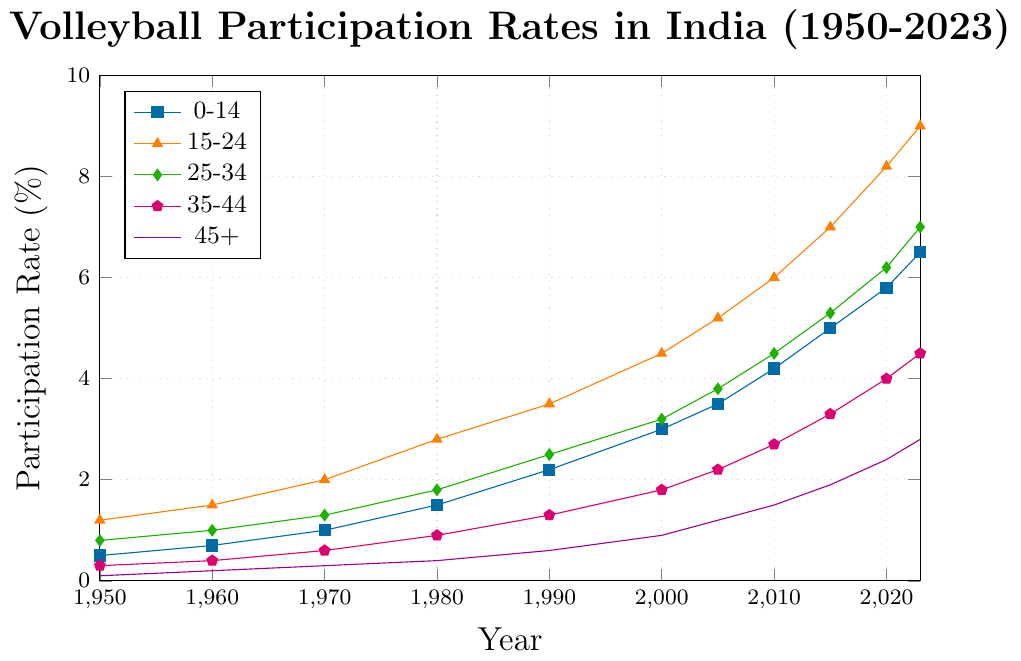What age group had the highest participation rate in 1980? Look at the data points for the year 1980; the age group 15-24 has the highest participation rate with a value of 2.8%.
Answer: 15-24 What is the difference in participation rates between age groups 15-24 and 0-14 in 2000? For the year 2000, look at the participation rates for age groups 15-24 (4.5%) and 0-14 (3.0%) and subtract them (4.5% - 3.0%).
Answer: 1.5% Which age group showed the greatest increase in participation rate from 1950 to 2023? By comparing the starting and ending values for each age group, the 15-24 age group had the highest increase (9.0% in 2023 - 1.2% in 1950 = 7.8%).
Answer: 15-24 In 1990, how many percentage points higher was the participation rate for the age group 25-34 compared to the age group 45+? Look at the data points for the year 1990; age group 25-34 is at 2.5% and age group 45+ is at 0.6%. Subtract them (2.5% - 0.6%).
Answer: 1.9% What is the average participation rate for the 25-34 age group from 1950 to 2023? Sum the values for the 25-34 age group from 1950 to 2023 (0.8 + 1.0 + 1.3 + 1.8 + 2.5 + 3.2 + 3.8 + 4.5 + 5.3 + 6.2 + 7.0) and then divide by the number of data points (11).
Answer: 3.6% Which age group had the lowest participation rate in 2023? Look at the data points for the year 2023; the age group 45+ has the lowest participation rate with a value of 2.8%.
Answer: 45+ Across all years, which two age groups had the most similar trends in participation rates? Visually, the age groups 0-14 and 35-44 seem to have similar trends in participation rates, both showing steady increases over time.
Answer: 0-14 and 35-44 What is the sum of participation rates for the age group 35-44 in the years 1970 and 1990? Sum the values for the 35-44 age group in the years 1970 and 1990 (0.6 + 1.3).
Answer: 1.9 How did the participation rate for the 0-14 age group change from 1960 to 1980? Look at the participation rates for the 0-14 age group in 1960 (0.7%) and 1980 (1.5%) and find the difference (1.5% - 0.7%).
Answer: Increased by 0.8% 